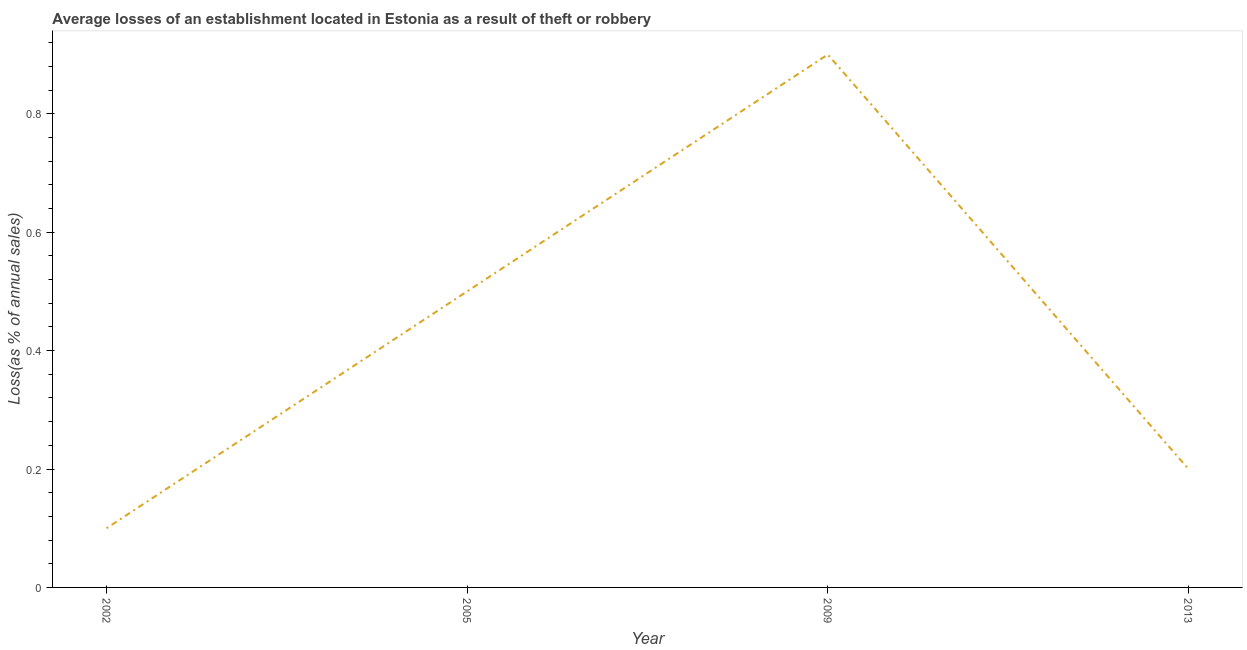In which year was the losses due to theft maximum?
Give a very brief answer. 2009. What is the sum of the losses due to theft?
Offer a very short reply. 1.7. What is the average losses due to theft per year?
Make the answer very short. 0.42. What is the median losses due to theft?
Keep it short and to the point. 0.35. In how many years, is the losses due to theft greater than 0.7200000000000001 %?
Offer a terse response. 1. What is the ratio of the losses due to theft in 2005 to that in 2009?
Your response must be concise. 0.56. Does the losses due to theft monotonically increase over the years?
Your answer should be compact. No. How many lines are there?
Your answer should be very brief. 1. Are the values on the major ticks of Y-axis written in scientific E-notation?
Make the answer very short. No. What is the title of the graph?
Ensure brevity in your answer.  Average losses of an establishment located in Estonia as a result of theft or robbery. What is the label or title of the X-axis?
Provide a succinct answer. Year. What is the label or title of the Y-axis?
Your answer should be compact. Loss(as % of annual sales). What is the Loss(as % of annual sales) in 2002?
Your response must be concise. 0.1. What is the Loss(as % of annual sales) of 2005?
Offer a terse response. 0.5. What is the Loss(as % of annual sales) of 2013?
Your answer should be very brief. 0.2. What is the difference between the Loss(as % of annual sales) in 2002 and 2009?
Make the answer very short. -0.8. What is the difference between the Loss(as % of annual sales) in 2002 and 2013?
Keep it short and to the point. -0.1. What is the difference between the Loss(as % of annual sales) in 2009 and 2013?
Your response must be concise. 0.7. What is the ratio of the Loss(as % of annual sales) in 2002 to that in 2005?
Give a very brief answer. 0.2. What is the ratio of the Loss(as % of annual sales) in 2002 to that in 2009?
Your response must be concise. 0.11. What is the ratio of the Loss(as % of annual sales) in 2002 to that in 2013?
Your answer should be very brief. 0.5. What is the ratio of the Loss(as % of annual sales) in 2005 to that in 2009?
Provide a short and direct response. 0.56. What is the ratio of the Loss(as % of annual sales) in 2005 to that in 2013?
Offer a terse response. 2.5. What is the ratio of the Loss(as % of annual sales) in 2009 to that in 2013?
Your answer should be compact. 4.5. 